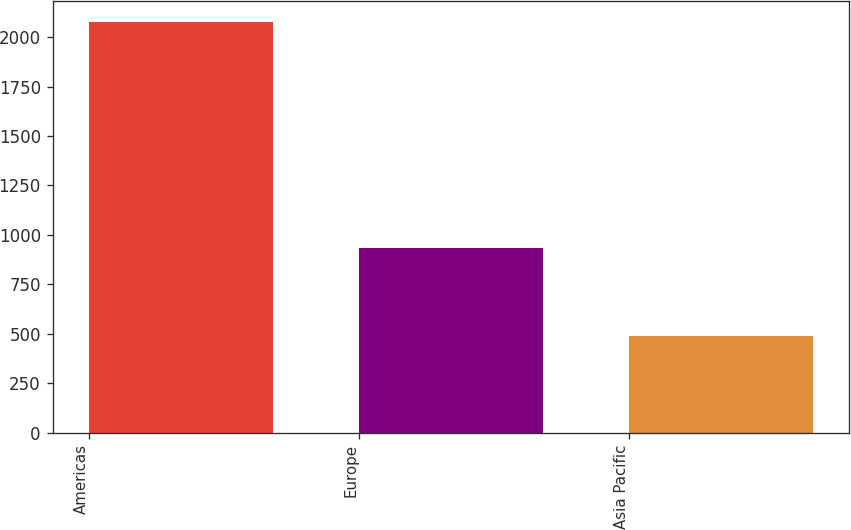Convert chart to OTSL. <chart><loc_0><loc_0><loc_500><loc_500><bar_chart><fcel>Americas<fcel>Europe<fcel>Asia Pacific<nl><fcel>2076.5<fcel>931.1<fcel>487.8<nl></chart> 